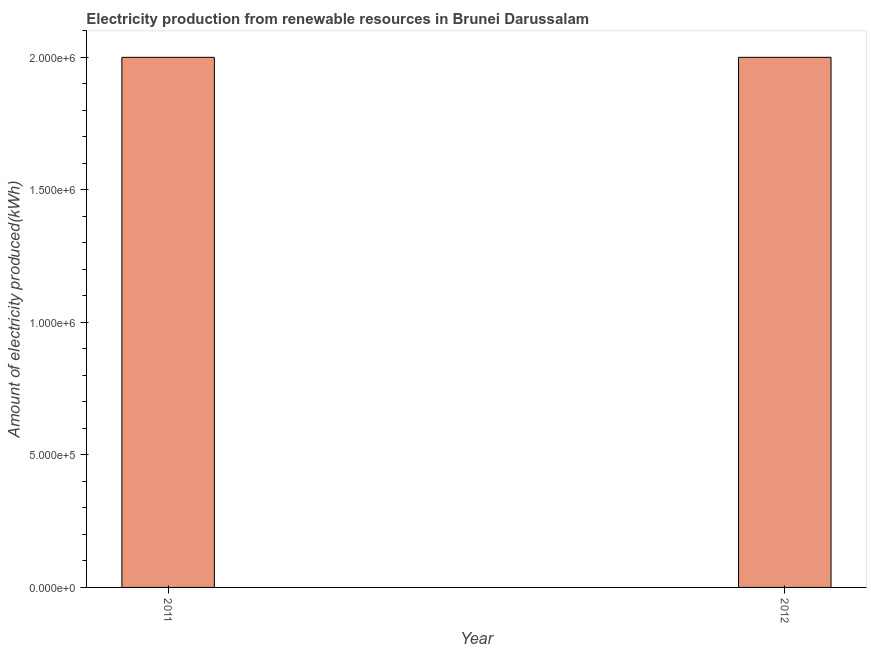Does the graph contain any zero values?
Your answer should be very brief. No. What is the title of the graph?
Your response must be concise. Electricity production from renewable resources in Brunei Darussalam. What is the label or title of the X-axis?
Your answer should be very brief. Year. What is the label or title of the Y-axis?
Provide a short and direct response. Amount of electricity produced(kWh). What is the amount of electricity produced in 2011?
Offer a very short reply. 2.00e+06. What is the average amount of electricity produced per year?
Provide a succinct answer. 2.00e+06. Do a majority of the years between 2011 and 2012 (inclusive) have amount of electricity produced greater than 1500000 kWh?
Offer a terse response. Yes. Is the amount of electricity produced in 2011 less than that in 2012?
Your answer should be compact. No. How many bars are there?
Offer a very short reply. 2. What is the difference between two consecutive major ticks on the Y-axis?
Give a very brief answer. 5.00e+05. Are the values on the major ticks of Y-axis written in scientific E-notation?
Give a very brief answer. Yes. What is the Amount of electricity produced(kWh) in 2012?
Make the answer very short. 2.00e+06. 